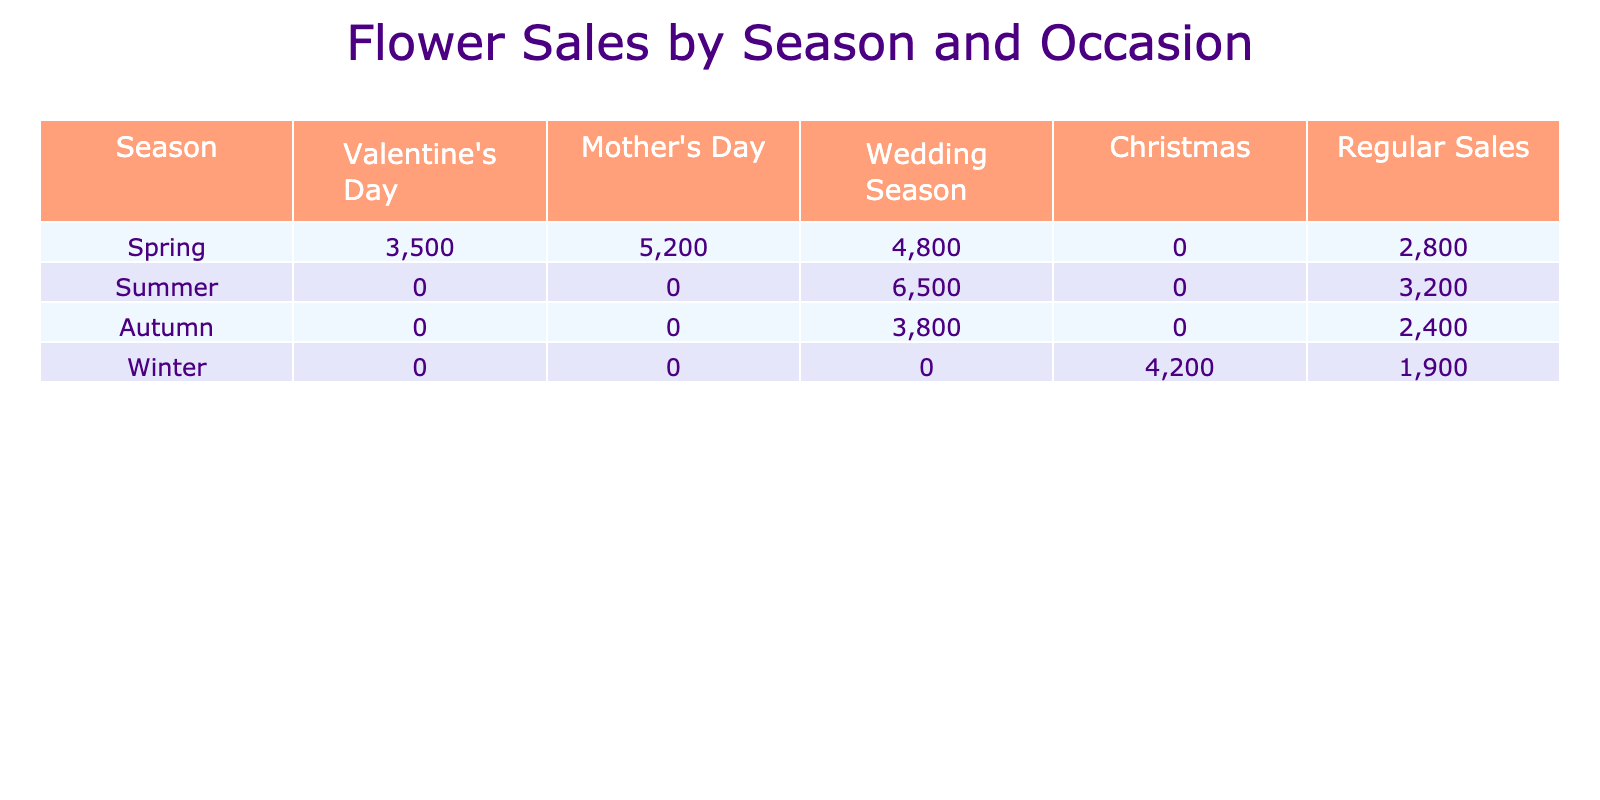What season has the highest flower sales for Valentine's Day? Looking at the Valentine's Day column, Spring has the highest sales with 3500, whereas other seasons have 0 sales.
Answer: Spring What is the total sales for Mother's Day across all seasons? By adding the Mother's Day sales: 5200 (Spring) + 0 (Summer) + 0 (Autumn) + 0 (Winter) = 5200.
Answer: 5200 Is there any flower sales recorded for Autumn during Christmas? The Christmas column for Autumn shows 0 sales, indicating no flowers were sold during this occasion in that season.
Answer: No Which season has the lowest flower sales for weddings? The minimum wedding sales occur in Winter, where the flower sales are recorded as 0. Other seasons have higher sales.
Answer: Winter What is the average flower sales for Regular Sales across all seasons? To find the average: (2800 + 3200 + 2400 + 1900) / 4 = 10300 / 4 = 2575.
Answer: 2575 How do Summer flower sales for weddings compare to Spring flower sales for weddings? Spring sales for weddings are 4800 while Summer sales are 6500. Summer has higher sales than Spring; specifically, it is 1700 more.
Answer: Summer has higher sales During which occasion do we see the peak flower sales in the table? The highest sales are recorded during the wedding season in Summer with 6500, making it the peak occasion.
Answer: Wedding Season What are the total flower sales for Winter compared to Spring? Winter total is 4200 (Christmas) + 1900 (Regular Sales) = 6100. Spring total is 3500 + 5200 + 4800 + 0 + 2800 = 15800. Therefore, Spring has higher sales than Winter.
Answer: Spring has higher sales Which occasion has no recorded sales in Autumn? Both Mother's Day and Christmas have 0 recorded sales in Autumn, as seen in their respective columns.
Answer: Mother's Day and Christmas What is the difference in flower sales for weddings between Spring and Autumn? Spring wedding sales are 4800 while Autumn sales are 3800. The difference is 4800 - 3800 = 1000.
Answer: 1000 